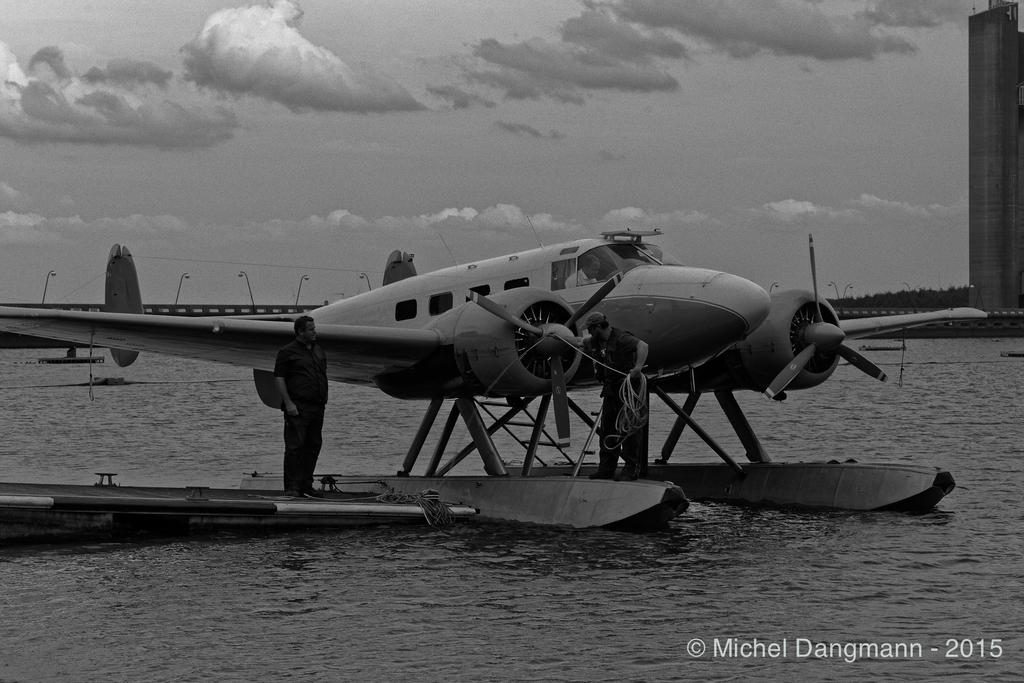<image>
Share a concise interpretation of the image provided. the plane and man photo image was taken in 2015 